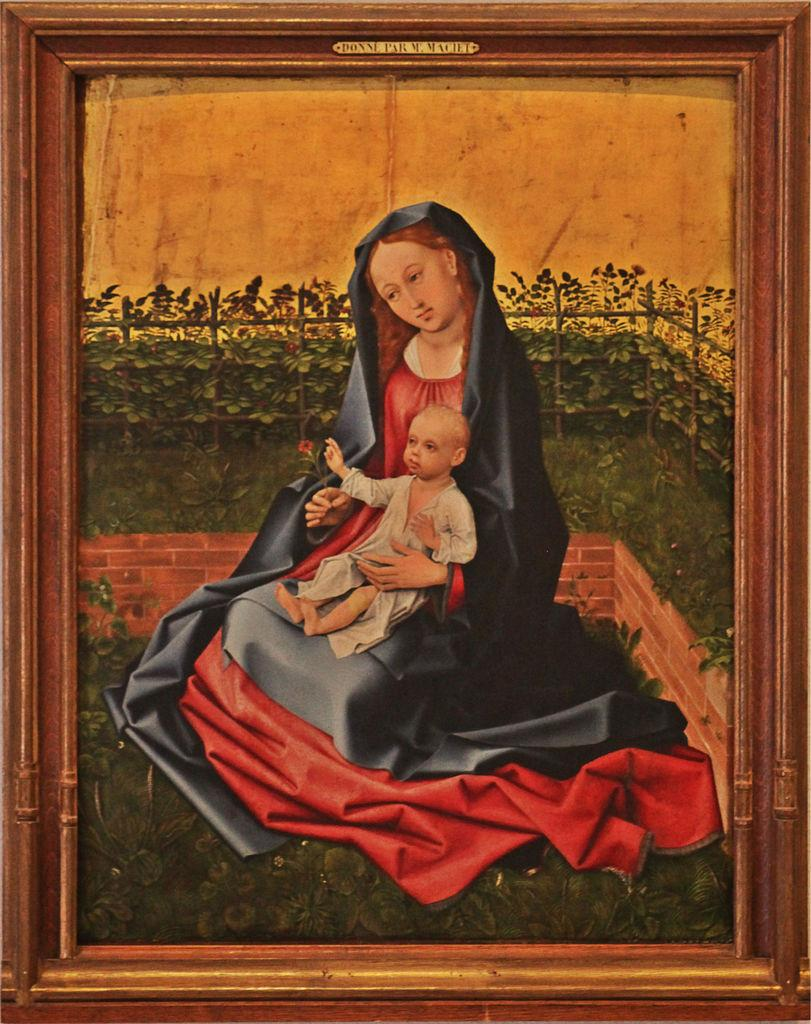<image>
Offer a succinct explanation of the picture presented. framed painting labeled DONNE PARM MACIET of woman holding a child 